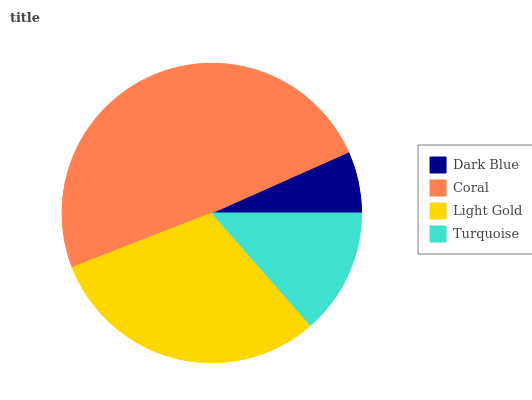Is Dark Blue the minimum?
Answer yes or no. Yes. Is Coral the maximum?
Answer yes or no. Yes. Is Light Gold the minimum?
Answer yes or no. No. Is Light Gold the maximum?
Answer yes or no. No. Is Coral greater than Light Gold?
Answer yes or no. Yes. Is Light Gold less than Coral?
Answer yes or no. Yes. Is Light Gold greater than Coral?
Answer yes or no. No. Is Coral less than Light Gold?
Answer yes or no. No. Is Light Gold the high median?
Answer yes or no. Yes. Is Turquoise the low median?
Answer yes or no. Yes. Is Dark Blue the high median?
Answer yes or no. No. Is Dark Blue the low median?
Answer yes or no. No. 